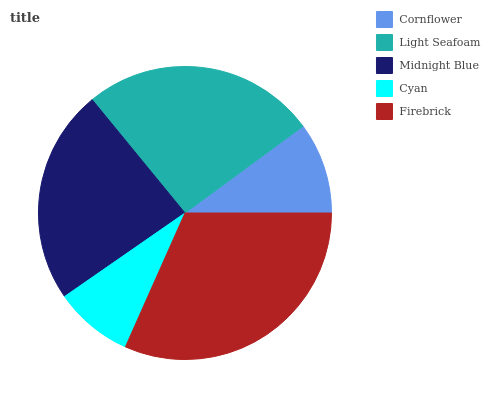Is Cyan the minimum?
Answer yes or no. Yes. Is Firebrick the maximum?
Answer yes or no. Yes. Is Light Seafoam the minimum?
Answer yes or no. No. Is Light Seafoam the maximum?
Answer yes or no. No. Is Light Seafoam greater than Cornflower?
Answer yes or no. Yes. Is Cornflower less than Light Seafoam?
Answer yes or no. Yes. Is Cornflower greater than Light Seafoam?
Answer yes or no. No. Is Light Seafoam less than Cornflower?
Answer yes or no. No. Is Midnight Blue the high median?
Answer yes or no. Yes. Is Midnight Blue the low median?
Answer yes or no. Yes. Is Cornflower the high median?
Answer yes or no. No. Is Light Seafoam the low median?
Answer yes or no. No. 